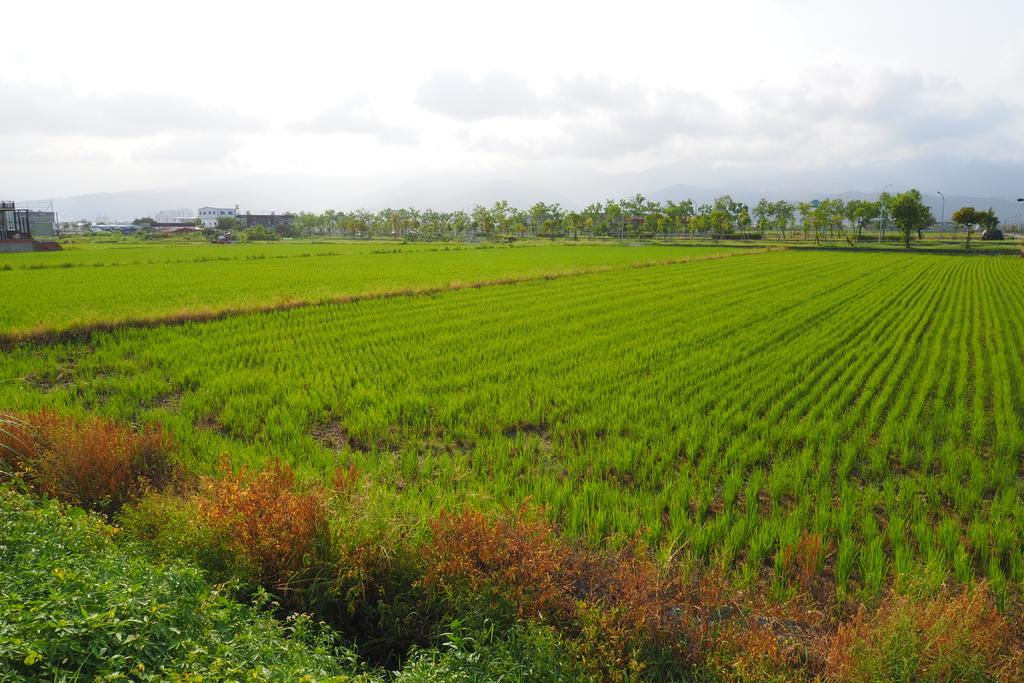What type of vegetation is present in the image? There is a group of plants and trees in the image. What can be seen in the background of the image? There are buildings and the sky visible in the background of the image. How would you describe the sky in the image? The sky appears to be cloudy in the image. Is there a horse standing near the stove in the image? There is no horse or stove present in the image. 